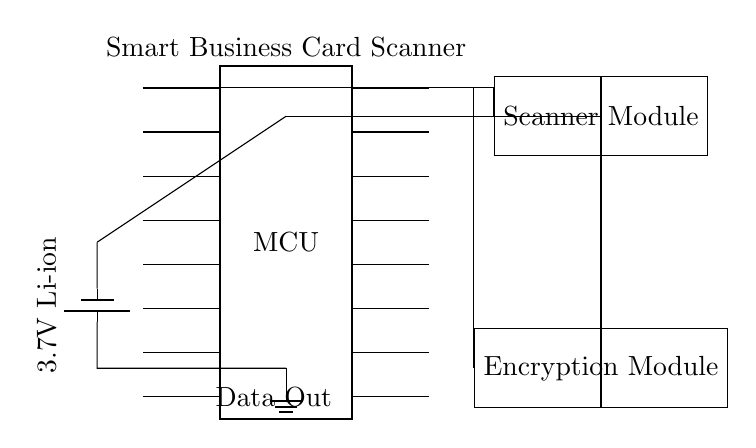What is the main component in this circuit? The circuit diagram prominently features a microcontroller, indicated by the label MCU. This component is central as it manages the operations of the scanner and encryption modules.
Answer: microcontroller What is the power source voltage? The circuit diagram shows a battery labeled 3.7V Li-ion, which indicates the voltage supplied to power the whole circuit.
Answer: 3.7V How many pins does the microcontroller have? The microcontroller in the diagram is represented as having 16 pins, which is specified in its description. This direct identification aids in understanding its connectivity.
Answer: 16 Which module processes data? The circuit identifies the scanner module as the one responsible for processing data, as indicated by its label and connection to the microcontroller.
Answer: Scanner Module Explain the relationship between the encryption module and the microcontroller. The encryption module is connected to the microcontroller via a direct connection from one of its pins, which indicates that it depends on the microcontroller for instructions or data processing. This shows the module's functionality as a dependent entity to enhance security in the scanning process.
Answer: Dependent What is the purpose of the encryption module in this circuit? The encryption module is included to secure the data processed by the scanner before it is output. This purpose is crucial for protecting sensitive information captured from business cards. Its role is indicated clearly in its label and association with the data flow direction in the circuit.
Answer: Data Security What outputs does the circuit provide? The diagram indicates a Data Out connection originating from the microcontroller, which designates where processed data will be sent, confirming it serves an output function.
Answer: Data Out 